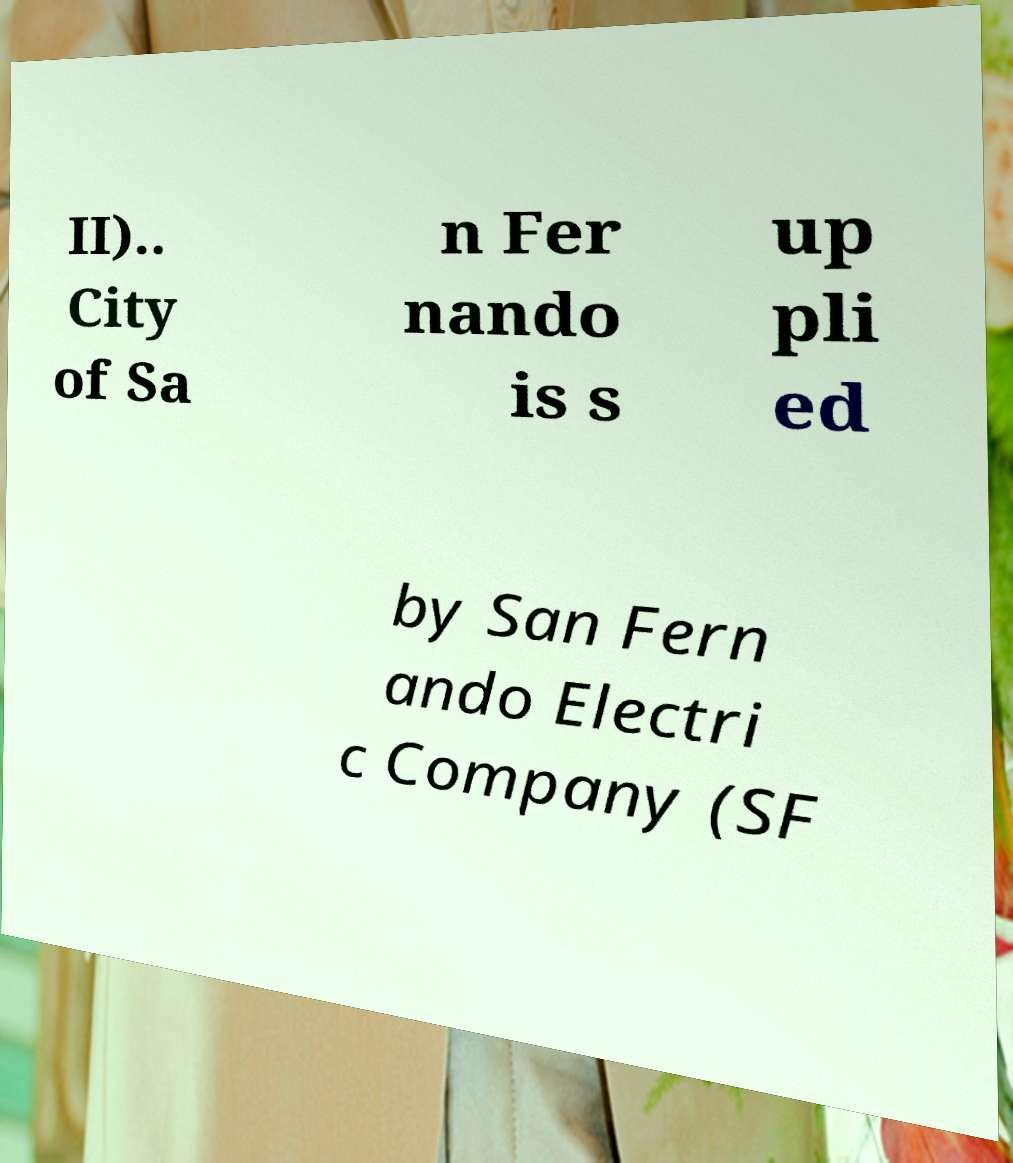I need the written content from this picture converted into text. Can you do that? II).. City of Sa n Fer nando is s up pli ed by San Fern ando Electri c Company (SF 